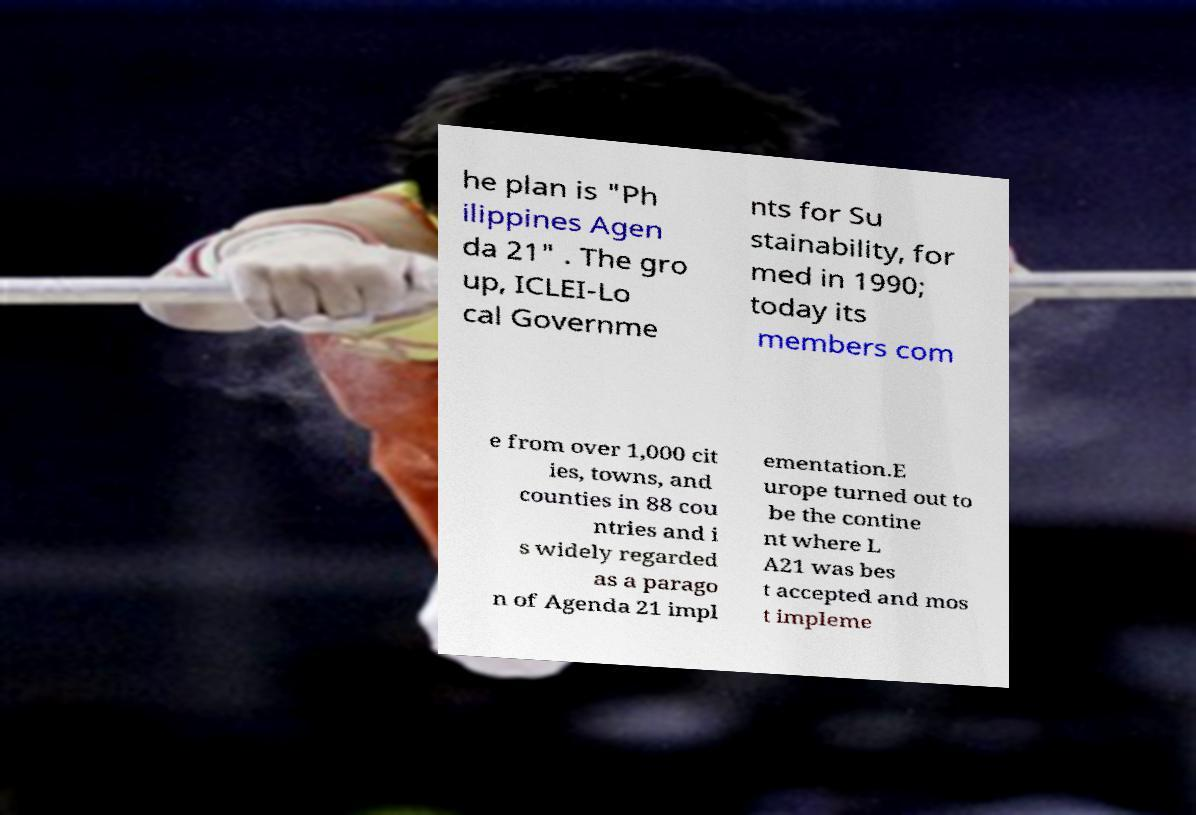Please read and relay the text visible in this image. What does it say? he plan is "Ph ilippines Agen da 21" . The gro up, ICLEI-Lo cal Governme nts for Su stainability, for med in 1990; today its members com e from over 1,000 cit ies, towns, and counties in 88 cou ntries and i s widely regarded as a parago n of Agenda 21 impl ementation.E urope turned out to be the contine nt where L A21 was bes t accepted and mos t impleme 